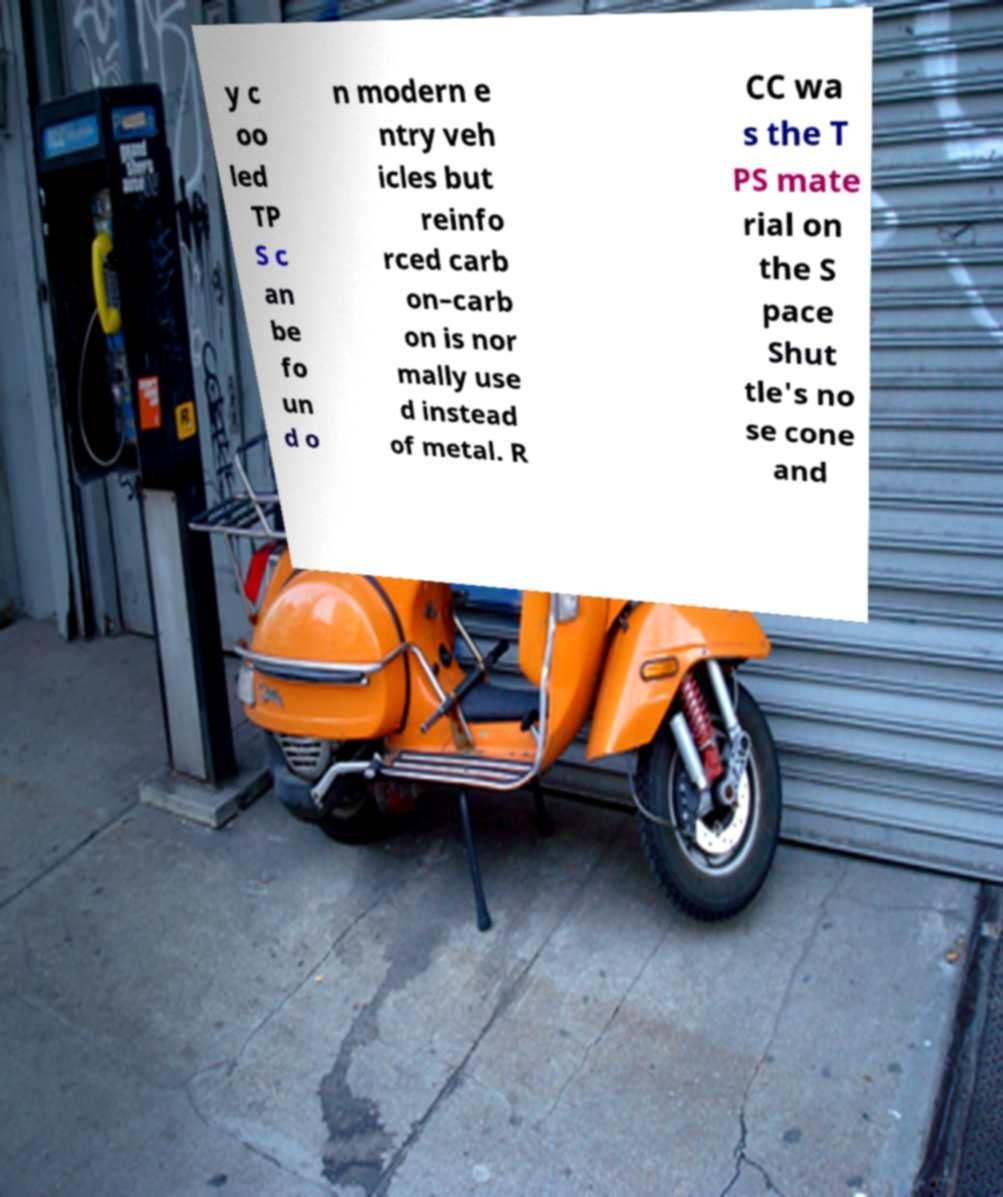For documentation purposes, I need the text within this image transcribed. Could you provide that? y c oo led TP S c an be fo un d o n modern e ntry veh icles but reinfo rced carb on–carb on is nor mally use d instead of metal. R CC wa s the T PS mate rial on the S pace Shut tle's no se cone and 